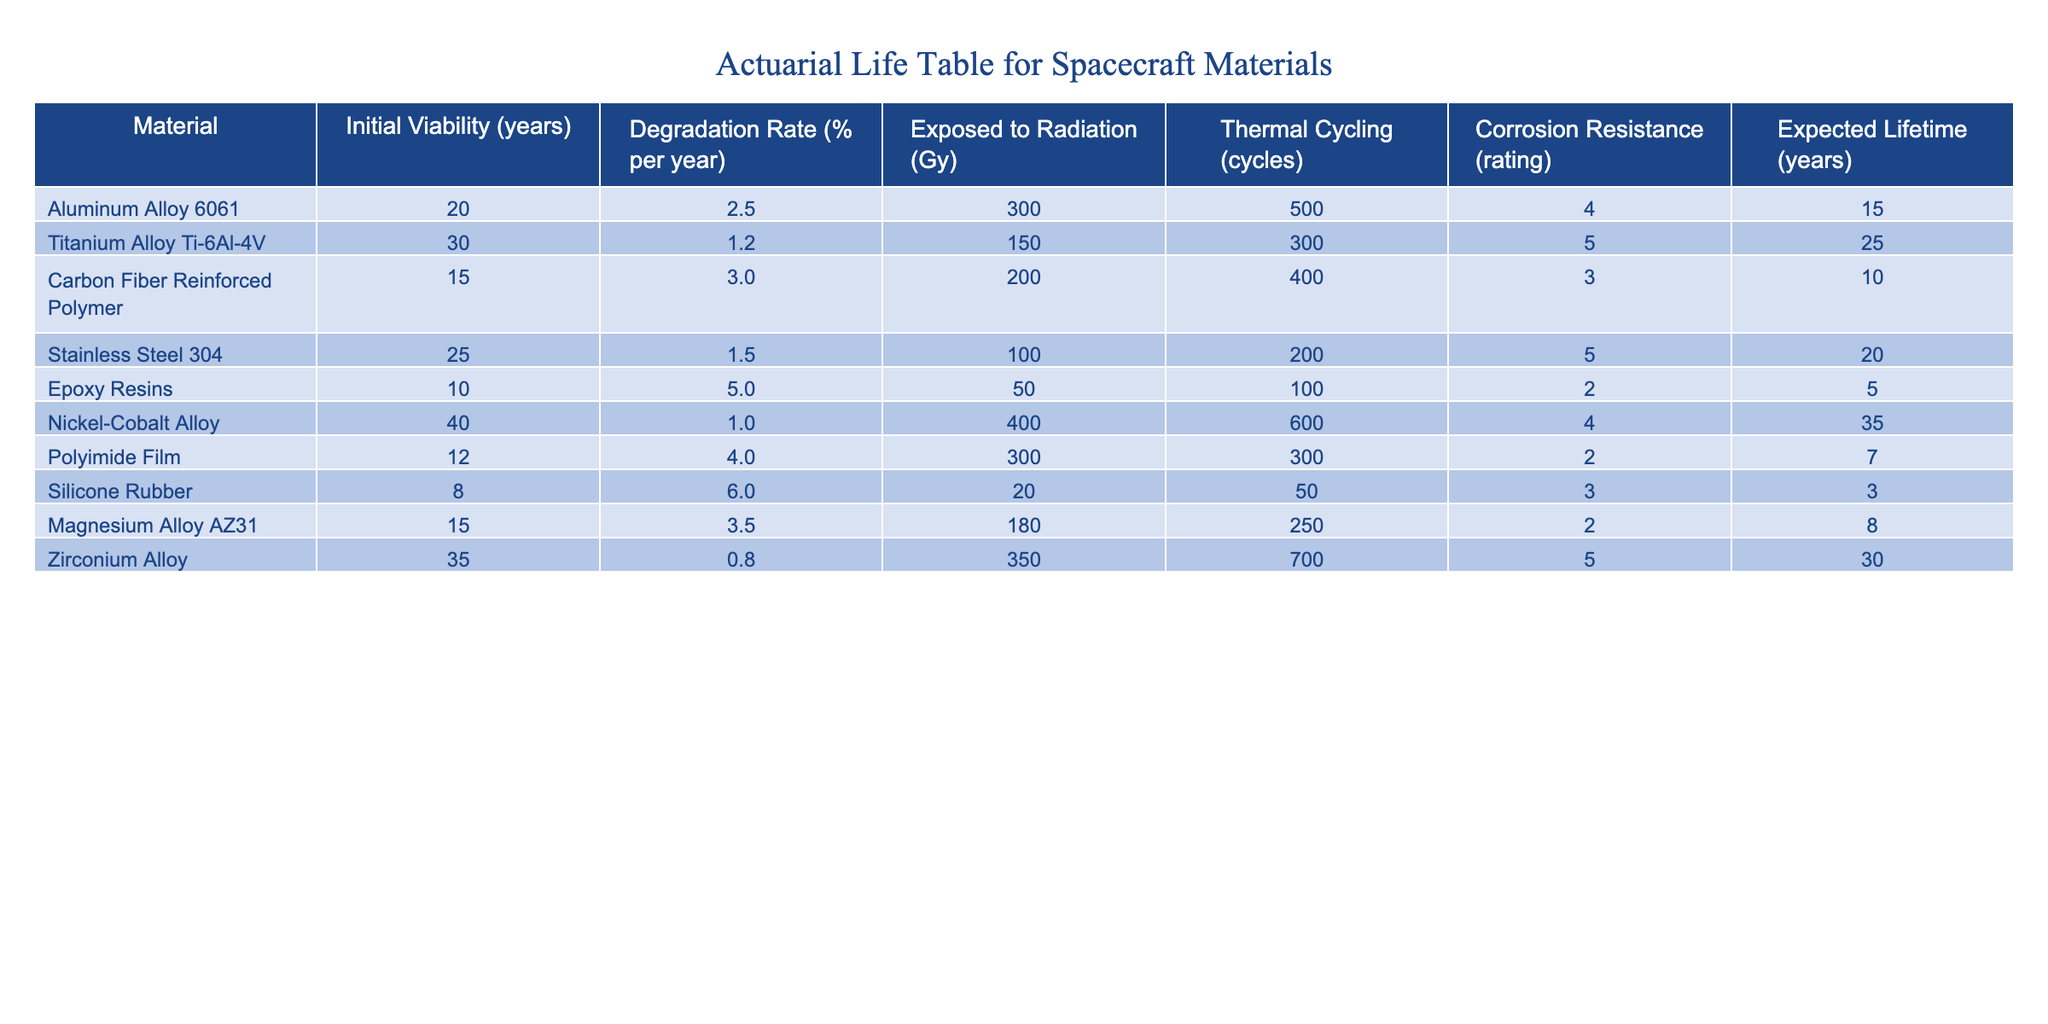What is the expected lifetime of the Aluminum Alloy 6061? The expected lifetime of Aluminum Alloy 6061 is listed directly in the table under the "Expected Lifetime" column as 15 years.
Answer: 15 years Which material has the highest initial viability? The initial viability values are given for each material, and Nickel-Cobalt Alloy has the highest Initial Viability at 40 years.
Answer: Nickel-Cobalt Alloy What is the average degradation rate of the materials listed? To find the average degradation rate, we sum the degradation rates of all materials: (2.5 + 1.2 + 3.0 + 1.5 + 5.0 + 1.0 + 4.0 + 6.0 + 3.5 + 0.8) = 29.5%. Dividing by the number of materials (10), the average degradation rate is 29.5% / 10 = 2.95%.
Answer: 2.95% Does Titanium Alloy Ti-6Al-4V have better corrosion resistance than the Carbon Fiber Reinforced Polymer? Titanium Alloy Ti-6Al-4V has a corrosion resistance rating of 5, while Carbon Fiber Reinforced Polymer has a rating of 3, indicating that Titanium Alloy has better corrosion resistance.
Answer: Yes What is the difference in expected lifetime between the materials with the highest and lowest lifetimes? The material with the highest expected lifetime is Nickel-Cobalt Alloy at 35 years, and the lowest is Silicone Rubber at 3 years. The difference is calculated as 35 - 3 = 32 years.
Answer: 32 years Which material has the least exposure to thermal cycling, and what is its value? By examining the "Thermal Cycling" column, Epoxy Resins have the least exposure to thermal cycling at 100 cycles.
Answer: Epoxy Resins, 100 cycles Is it true that all materials are expected to degrade over time? All materials have a degradation rate mentioned in the table, which implies that they all are expected to degrade over time.
Answer: Yes What is the total expected lifetime of the materials with a degradation rate less than 2.0% per year? The materials with degradation rates less than 2.0% are Titanium Alloy Ti-6Al-4V (25 years) and Zirconium Alloy (30 years). Their total expected lifetime is 25 + 30 = 55 years.
Answer: 55 years 